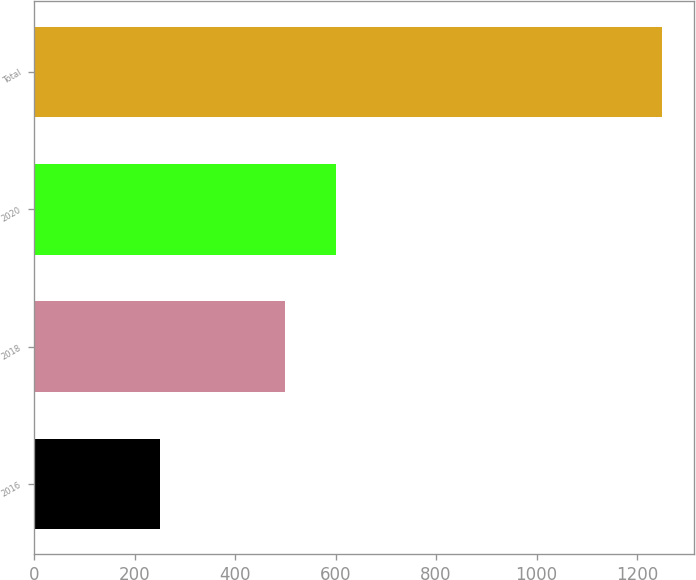Convert chart to OTSL. <chart><loc_0><loc_0><loc_500><loc_500><bar_chart><fcel>2016<fcel>2018<fcel>2020<fcel>Total<nl><fcel>250<fcel>500<fcel>600<fcel>1250<nl></chart> 